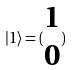<formula> <loc_0><loc_0><loc_500><loc_500>| 1 \rangle = ( \begin{matrix} 1 \\ 0 \end{matrix} )</formula> 